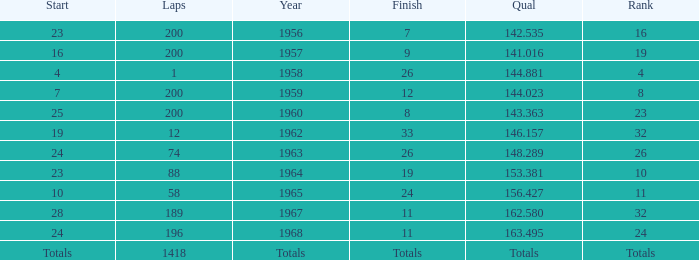Which qual has both 200 total laps and took place in 1957? 141.016. 